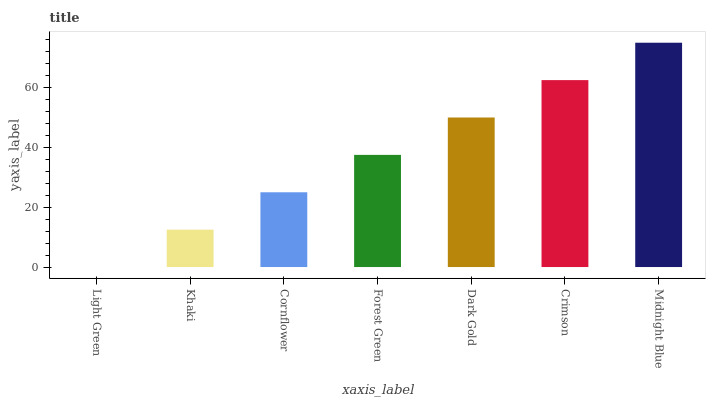Is Light Green the minimum?
Answer yes or no. Yes. Is Midnight Blue the maximum?
Answer yes or no. Yes. Is Khaki the minimum?
Answer yes or no. No. Is Khaki the maximum?
Answer yes or no. No. Is Khaki greater than Light Green?
Answer yes or no. Yes. Is Light Green less than Khaki?
Answer yes or no. Yes. Is Light Green greater than Khaki?
Answer yes or no. No. Is Khaki less than Light Green?
Answer yes or no. No. Is Forest Green the high median?
Answer yes or no. Yes. Is Forest Green the low median?
Answer yes or no. Yes. Is Light Green the high median?
Answer yes or no. No. Is Light Green the low median?
Answer yes or no. No. 